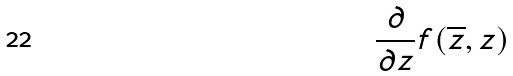<formula> <loc_0><loc_0><loc_500><loc_500>\frac { \partial } { \partial z } f ( \overline { z } , z )</formula> 